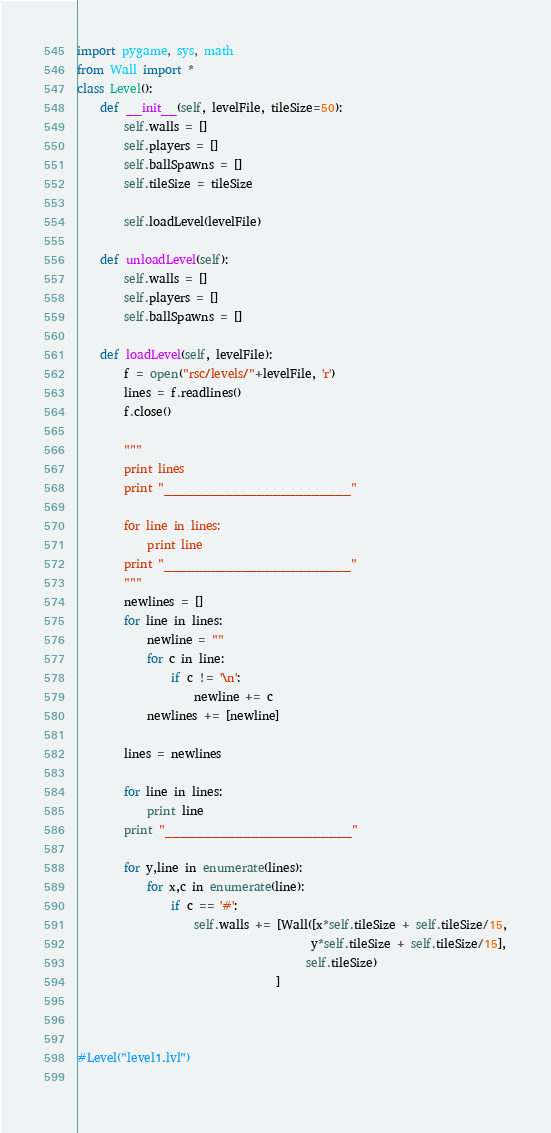<code> <loc_0><loc_0><loc_500><loc_500><_Python_>import pygame, sys, math
from Wall import *
class Level():
    def __init__(self, levelFile, tileSize=50):
        self.walls = []
        self.players = []
        self.ballSpawns = []
        self.tileSize = tileSize
        
        self.loadLevel(levelFile)
    
    def unloadLevel(self): 
        self.walls = []
        self.players = []
        self.ballSpawns = []
               
    def loadLevel(self, levelFile):        
        f = open("rsc/levels/"+levelFile, 'r')
        lines = f.readlines()
        f.close()
        
        """
        print lines
        print "________________________"
        
        for line in lines:
            print line
        print "________________________"
        """
        newlines = []
        for line in lines:
            newline = ""
            for c in line:
                if c != '\n':
                    newline += c
            newlines += [newline]
            
        lines = newlines
        
        for line in lines:
            print line
        print "________________________"
        
        for y,line in enumerate(lines):
            for x,c in enumerate(line):
                if c == '#':
                    self.walls += [Wall([x*self.tileSize + self.tileSize/15,
                                        y*self.tileSize + self.tileSize/15],
                                       self.tileSize)
                                  ]
                                                

        
#Level("level1.lvl")
            

</code> 